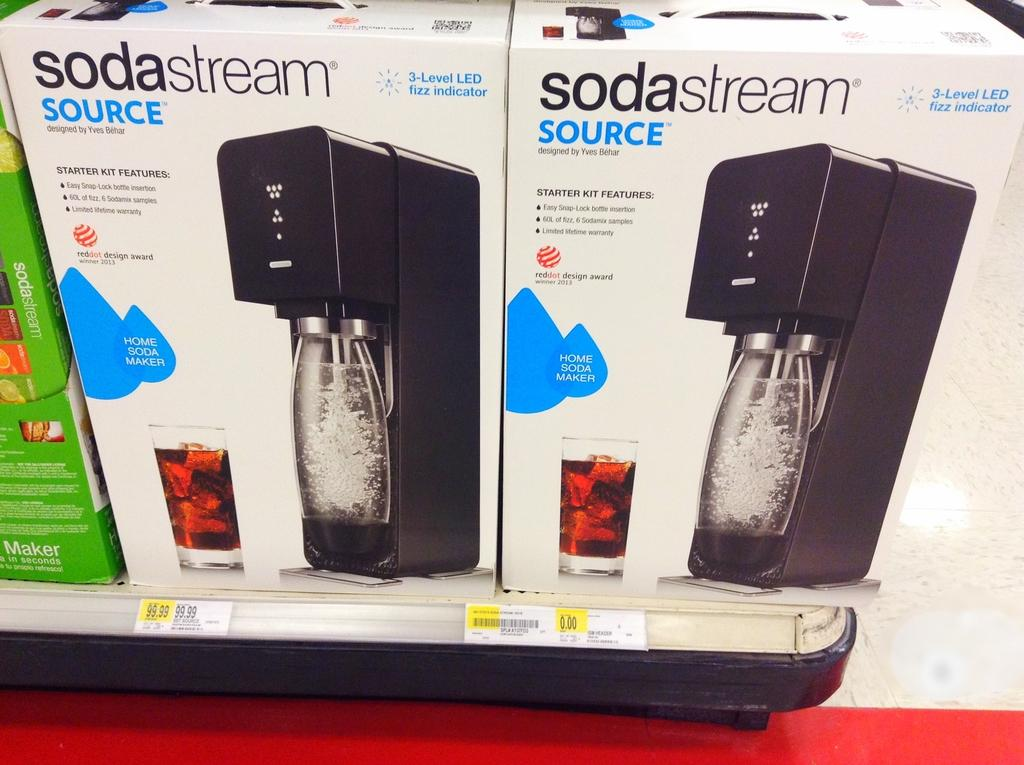<image>
Create a compact narrative representing the image presented. A box of soda stream source written on the side. 